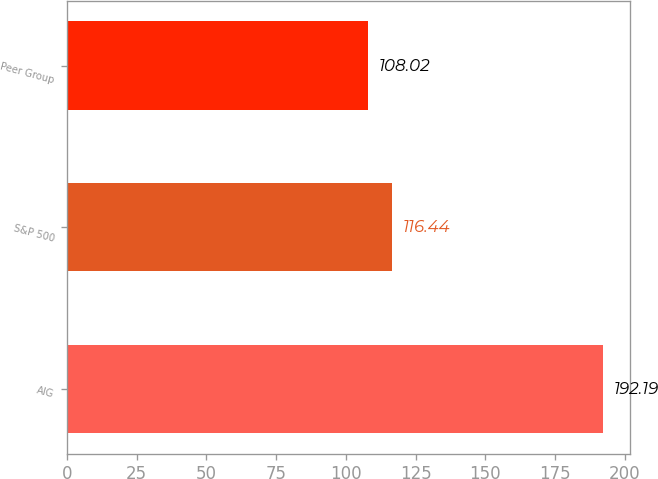<chart> <loc_0><loc_0><loc_500><loc_500><bar_chart><fcel>AIG<fcel>S&P 500<fcel>Peer Group<nl><fcel>192.19<fcel>116.44<fcel>108.02<nl></chart> 